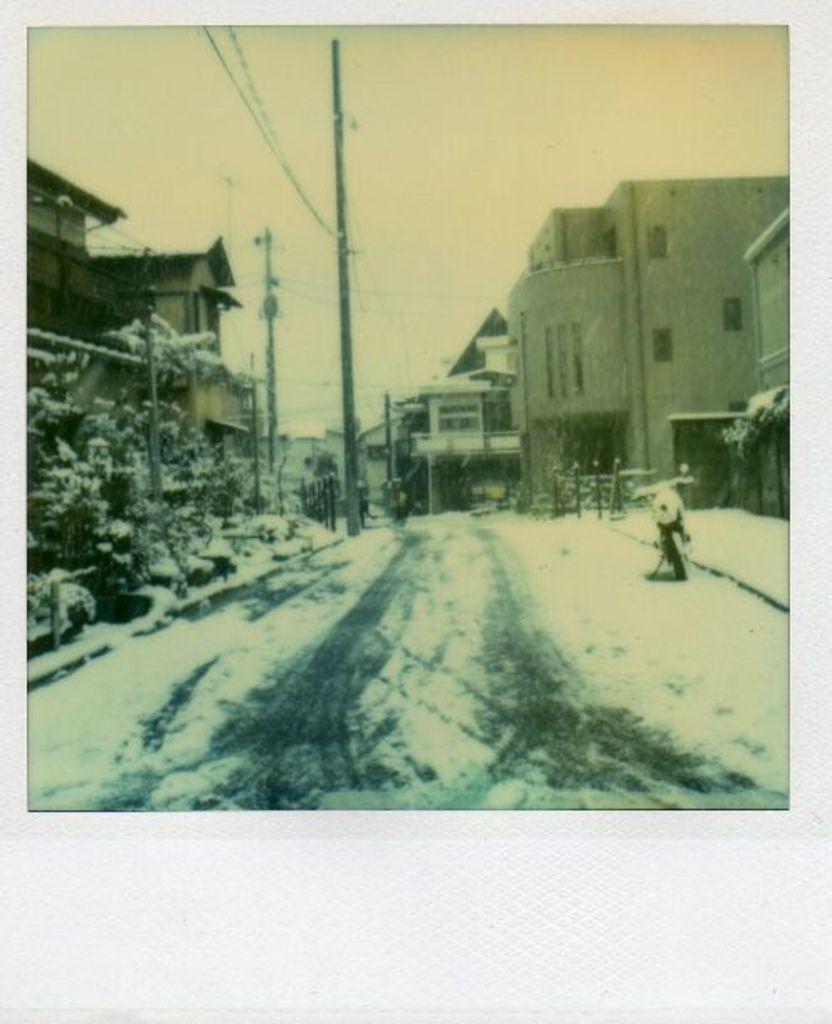Please provide a concise description of this image. In the center of the image there is a road. There is snow. There is a vehicle. There are buildings. There are electric poles and wires. At the top of the image there is sky. 